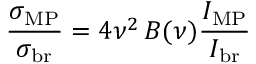Convert formula to latex. <formula><loc_0><loc_0><loc_500><loc_500>\frac { \sigma _ { M P } } { \sigma _ { b r } } = 4 \nu ^ { 2 } \, B ( \nu ) \frac { I _ { M P } } { I _ { b r } }</formula> 